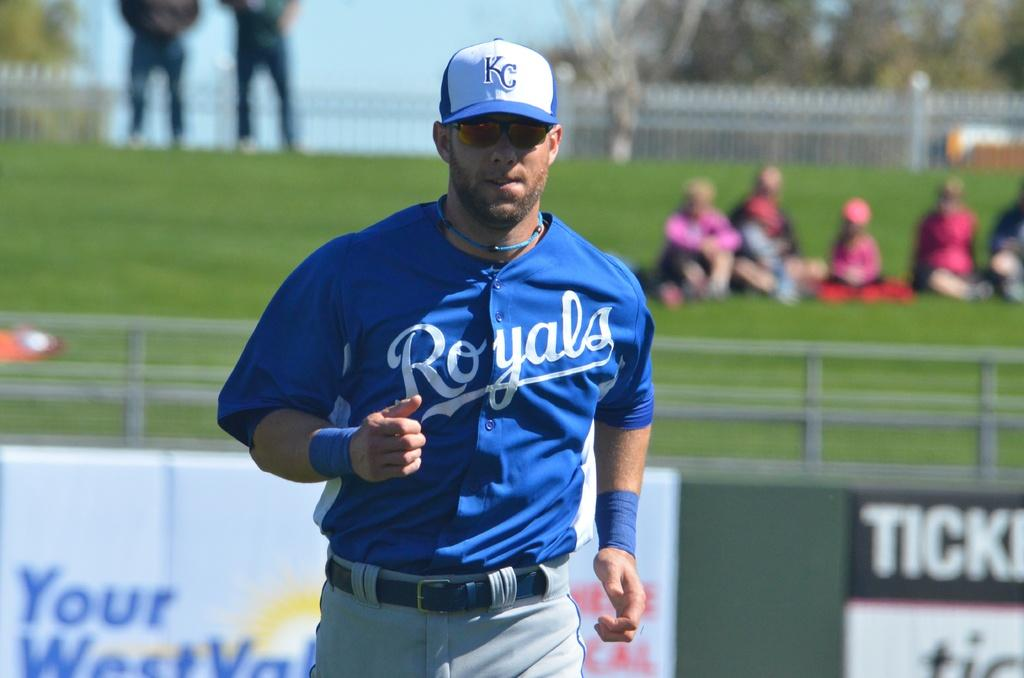<image>
Write a terse but informative summary of the picture. A member of the KC Royals apparently jogging. 